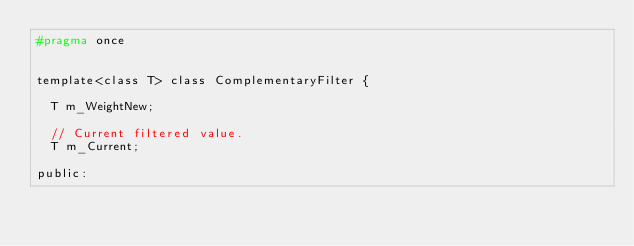<code> <loc_0><loc_0><loc_500><loc_500><_C_>#pragma once


template<class T> class ComplementaryFilter {

  T m_WeightNew;

  // Current filtered value. 
  T m_Current;

public:</code> 